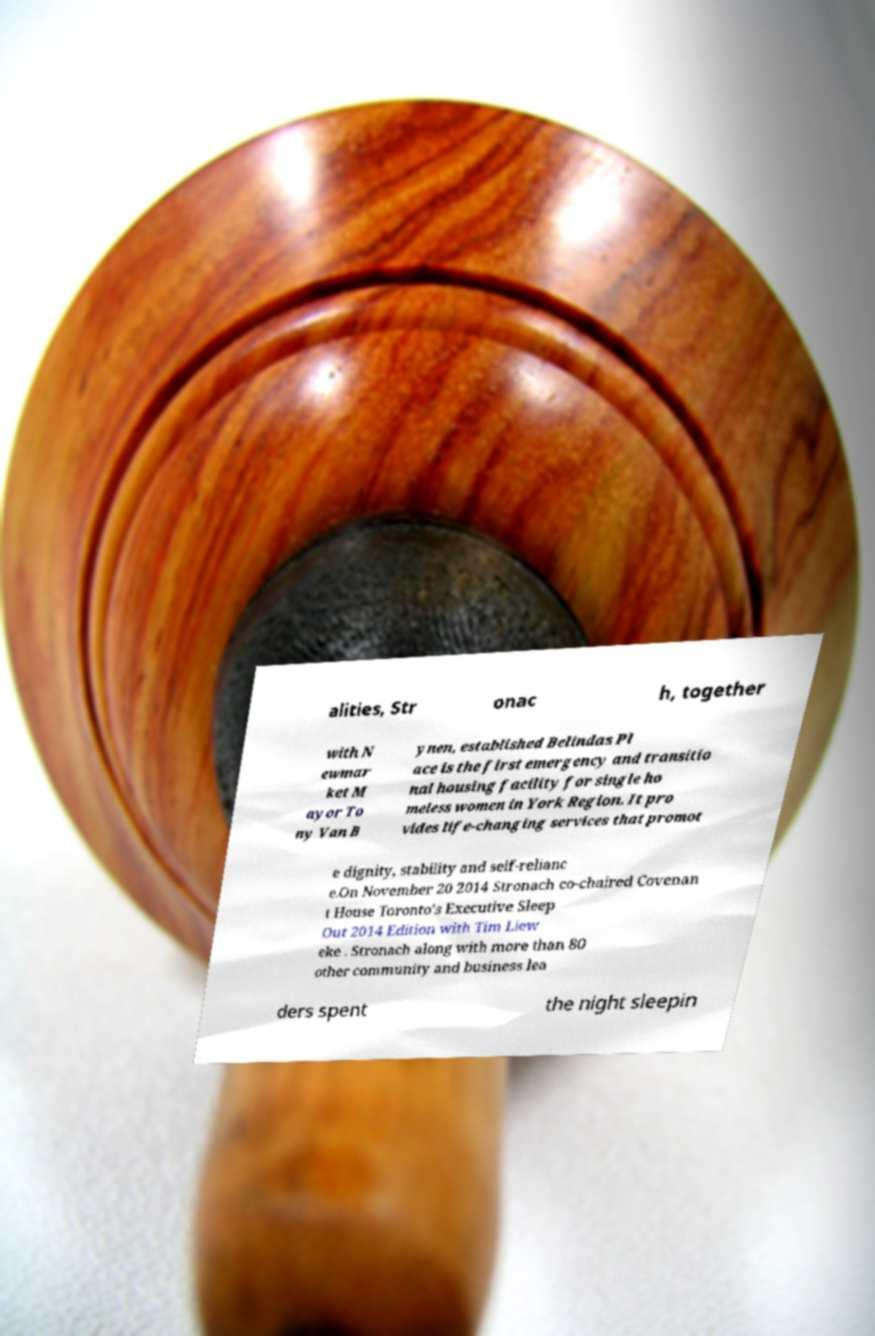Could you extract and type out the text from this image? alities, Str onac h, together with N ewmar ket M ayor To ny Van B ynen, established Belindas Pl ace is the first emergency and transitio nal housing facility for single ho meless women in York Region. It pro vides life-changing services that promot e dignity, stability and self-relianc e.On November 20 2014 Stronach co-chaired Covenan t House Toronto's Executive Sleep Out 2014 Edition with Tim Liew eke . Stronach along with more than 80 other community and business lea ders spent the night sleepin 